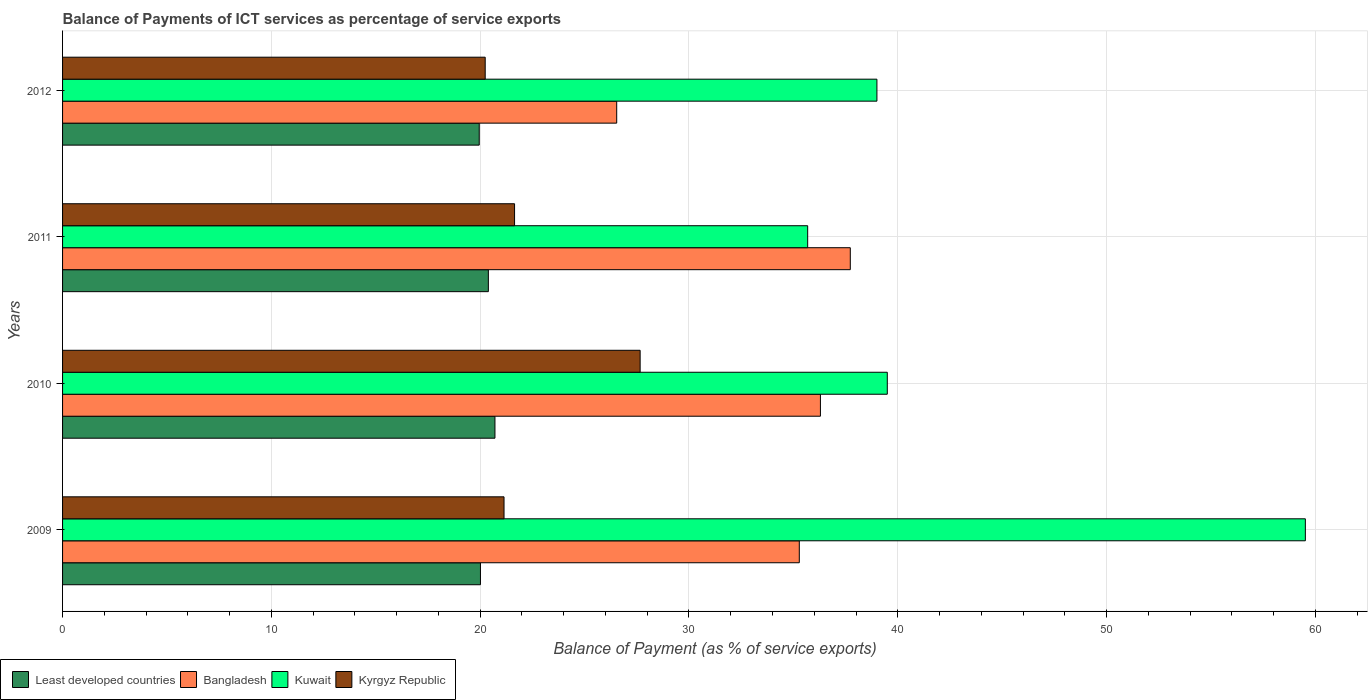How many groups of bars are there?
Provide a short and direct response. 4. Are the number of bars on each tick of the Y-axis equal?
Make the answer very short. Yes. How many bars are there on the 1st tick from the top?
Provide a short and direct response. 4. What is the balance of payments of ICT services in Bangladesh in 2010?
Offer a terse response. 36.29. Across all years, what is the maximum balance of payments of ICT services in Kyrgyz Republic?
Your answer should be compact. 27.66. Across all years, what is the minimum balance of payments of ICT services in Least developed countries?
Keep it short and to the point. 19.95. In which year was the balance of payments of ICT services in Bangladesh maximum?
Your response must be concise. 2011. What is the total balance of payments of ICT services in Kuwait in the graph?
Your answer should be compact. 173.7. What is the difference between the balance of payments of ICT services in Least developed countries in 2011 and that in 2012?
Offer a very short reply. 0.44. What is the difference between the balance of payments of ICT services in Bangladesh in 2010 and the balance of payments of ICT services in Kyrgyz Republic in 2012?
Your answer should be very brief. 16.05. What is the average balance of payments of ICT services in Bangladesh per year?
Provide a short and direct response. 33.96. In the year 2012, what is the difference between the balance of payments of ICT services in Least developed countries and balance of payments of ICT services in Bangladesh?
Offer a very short reply. -6.58. In how many years, is the balance of payments of ICT services in Kuwait greater than 20 %?
Provide a succinct answer. 4. What is the ratio of the balance of payments of ICT services in Kyrgyz Republic in 2011 to that in 2012?
Keep it short and to the point. 1.07. Is the difference between the balance of payments of ICT services in Least developed countries in 2009 and 2011 greater than the difference between the balance of payments of ICT services in Bangladesh in 2009 and 2011?
Offer a terse response. Yes. What is the difference between the highest and the second highest balance of payments of ICT services in Bangladesh?
Offer a terse response. 1.43. What is the difference between the highest and the lowest balance of payments of ICT services in Kyrgyz Republic?
Offer a very short reply. 7.42. Is it the case that in every year, the sum of the balance of payments of ICT services in Bangladesh and balance of payments of ICT services in Kuwait is greater than the sum of balance of payments of ICT services in Least developed countries and balance of payments of ICT services in Kyrgyz Republic?
Your response must be concise. No. What does the 3rd bar from the bottom in 2012 represents?
Provide a short and direct response. Kuwait. Is it the case that in every year, the sum of the balance of payments of ICT services in Bangladesh and balance of payments of ICT services in Kyrgyz Republic is greater than the balance of payments of ICT services in Kuwait?
Your answer should be very brief. No. Are all the bars in the graph horizontal?
Your answer should be compact. Yes. How many years are there in the graph?
Keep it short and to the point. 4. Are the values on the major ticks of X-axis written in scientific E-notation?
Offer a terse response. No. Does the graph contain any zero values?
Your answer should be very brief. No. How many legend labels are there?
Offer a terse response. 4. How are the legend labels stacked?
Offer a terse response. Horizontal. What is the title of the graph?
Provide a succinct answer. Balance of Payments of ICT services as percentage of service exports. Does "Heavily indebted poor countries" appear as one of the legend labels in the graph?
Your answer should be compact. No. What is the label or title of the X-axis?
Keep it short and to the point. Balance of Payment (as % of service exports). What is the Balance of Payment (as % of service exports) in Least developed countries in 2009?
Offer a very short reply. 20.01. What is the Balance of Payment (as % of service exports) in Bangladesh in 2009?
Offer a terse response. 35.28. What is the Balance of Payment (as % of service exports) of Kuwait in 2009?
Give a very brief answer. 59.52. What is the Balance of Payment (as % of service exports) in Kyrgyz Republic in 2009?
Offer a terse response. 21.14. What is the Balance of Payment (as % of service exports) in Least developed countries in 2010?
Provide a short and direct response. 20.71. What is the Balance of Payment (as % of service exports) in Bangladesh in 2010?
Your answer should be compact. 36.29. What is the Balance of Payment (as % of service exports) of Kuwait in 2010?
Keep it short and to the point. 39.5. What is the Balance of Payment (as % of service exports) in Kyrgyz Republic in 2010?
Give a very brief answer. 27.66. What is the Balance of Payment (as % of service exports) in Least developed countries in 2011?
Ensure brevity in your answer.  20.39. What is the Balance of Payment (as % of service exports) in Bangladesh in 2011?
Give a very brief answer. 37.73. What is the Balance of Payment (as % of service exports) of Kuwait in 2011?
Keep it short and to the point. 35.68. What is the Balance of Payment (as % of service exports) in Kyrgyz Republic in 2011?
Your answer should be very brief. 21.65. What is the Balance of Payment (as % of service exports) of Least developed countries in 2012?
Keep it short and to the point. 19.95. What is the Balance of Payment (as % of service exports) of Bangladesh in 2012?
Keep it short and to the point. 26.54. What is the Balance of Payment (as % of service exports) of Kuwait in 2012?
Provide a short and direct response. 39. What is the Balance of Payment (as % of service exports) of Kyrgyz Republic in 2012?
Offer a very short reply. 20.24. Across all years, what is the maximum Balance of Payment (as % of service exports) in Least developed countries?
Make the answer very short. 20.71. Across all years, what is the maximum Balance of Payment (as % of service exports) of Bangladesh?
Your answer should be compact. 37.73. Across all years, what is the maximum Balance of Payment (as % of service exports) in Kuwait?
Provide a succinct answer. 59.52. Across all years, what is the maximum Balance of Payment (as % of service exports) of Kyrgyz Republic?
Keep it short and to the point. 27.66. Across all years, what is the minimum Balance of Payment (as % of service exports) in Least developed countries?
Offer a terse response. 19.95. Across all years, what is the minimum Balance of Payment (as % of service exports) of Bangladesh?
Your answer should be compact. 26.54. Across all years, what is the minimum Balance of Payment (as % of service exports) in Kuwait?
Make the answer very short. 35.68. Across all years, what is the minimum Balance of Payment (as % of service exports) in Kyrgyz Republic?
Your answer should be very brief. 20.24. What is the total Balance of Payment (as % of service exports) of Least developed countries in the graph?
Your answer should be compact. 81.07. What is the total Balance of Payment (as % of service exports) of Bangladesh in the graph?
Give a very brief answer. 135.84. What is the total Balance of Payment (as % of service exports) in Kuwait in the graph?
Ensure brevity in your answer.  173.7. What is the total Balance of Payment (as % of service exports) of Kyrgyz Republic in the graph?
Your response must be concise. 90.69. What is the difference between the Balance of Payment (as % of service exports) in Least developed countries in 2009 and that in 2010?
Your response must be concise. -0.69. What is the difference between the Balance of Payment (as % of service exports) in Bangladesh in 2009 and that in 2010?
Your answer should be compact. -1.01. What is the difference between the Balance of Payment (as % of service exports) in Kuwait in 2009 and that in 2010?
Your answer should be very brief. 20.02. What is the difference between the Balance of Payment (as % of service exports) in Kyrgyz Republic in 2009 and that in 2010?
Provide a succinct answer. -6.52. What is the difference between the Balance of Payment (as % of service exports) in Least developed countries in 2009 and that in 2011?
Your response must be concise. -0.38. What is the difference between the Balance of Payment (as % of service exports) in Bangladesh in 2009 and that in 2011?
Give a very brief answer. -2.44. What is the difference between the Balance of Payment (as % of service exports) of Kuwait in 2009 and that in 2011?
Your answer should be very brief. 23.83. What is the difference between the Balance of Payment (as % of service exports) in Kyrgyz Republic in 2009 and that in 2011?
Ensure brevity in your answer.  -0.5. What is the difference between the Balance of Payment (as % of service exports) of Least developed countries in 2009 and that in 2012?
Offer a terse response. 0.06. What is the difference between the Balance of Payment (as % of service exports) in Bangladesh in 2009 and that in 2012?
Your answer should be very brief. 8.74. What is the difference between the Balance of Payment (as % of service exports) in Kuwait in 2009 and that in 2012?
Offer a very short reply. 20.52. What is the difference between the Balance of Payment (as % of service exports) of Kyrgyz Republic in 2009 and that in 2012?
Provide a succinct answer. 0.9. What is the difference between the Balance of Payment (as % of service exports) in Least developed countries in 2010 and that in 2011?
Keep it short and to the point. 0.32. What is the difference between the Balance of Payment (as % of service exports) of Bangladesh in 2010 and that in 2011?
Provide a succinct answer. -1.43. What is the difference between the Balance of Payment (as % of service exports) in Kuwait in 2010 and that in 2011?
Provide a succinct answer. 3.81. What is the difference between the Balance of Payment (as % of service exports) of Kyrgyz Republic in 2010 and that in 2011?
Make the answer very short. 6.01. What is the difference between the Balance of Payment (as % of service exports) of Least developed countries in 2010 and that in 2012?
Ensure brevity in your answer.  0.75. What is the difference between the Balance of Payment (as % of service exports) of Bangladesh in 2010 and that in 2012?
Provide a short and direct response. 9.76. What is the difference between the Balance of Payment (as % of service exports) in Kuwait in 2010 and that in 2012?
Keep it short and to the point. 0.5. What is the difference between the Balance of Payment (as % of service exports) in Kyrgyz Republic in 2010 and that in 2012?
Provide a succinct answer. 7.42. What is the difference between the Balance of Payment (as % of service exports) in Least developed countries in 2011 and that in 2012?
Your answer should be compact. 0.44. What is the difference between the Balance of Payment (as % of service exports) in Bangladesh in 2011 and that in 2012?
Offer a terse response. 11.19. What is the difference between the Balance of Payment (as % of service exports) of Kuwait in 2011 and that in 2012?
Ensure brevity in your answer.  -3.32. What is the difference between the Balance of Payment (as % of service exports) of Kyrgyz Republic in 2011 and that in 2012?
Your response must be concise. 1.41. What is the difference between the Balance of Payment (as % of service exports) of Least developed countries in 2009 and the Balance of Payment (as % of service exports) of Bangladesh in 2010?
Your answer should be very brief. -16.28. What is the difference between the Balance of Payment (as % of service exports) in Least developed countries in 2009 and the Balance of Payment (as % of service exports) in Kuwait in 2010?
Give a very brief answer. -19.48. What is the difference between the Balance of Payment (as % of service exports) of Least developed countries in 2009 and the Balance of Payment (as % of service exports) of Kyrgyz Republic in 2010?
Make the answer very short. -7.65. What is the difference between the Balance of Payment (as % of service exports) of Bangladesh in 2009 and the Balance of Payment (as % of service exports) of Kuwait in 2010?
Offer a very short reply. -4.21. What is the difference between the Balance of Payment (as % of service exports) of Bangladesh in 2009 and the Balance of Payment (as % of service exports) of Kyrgyz Republic in 2010?
Your response must be concise. 7.62. What is the difference between the Balance of Payment (as % of service exports) in Kuwait in 2009 and the Balance of Payment (as % of service exports) in Kyrgyz Republic in 2010?
Keep it short and to the point. 31.86. What is the difference between the Balance of Payment (as % of service exports) in Least developed countries in 2009 and the Balance of Payment (as % of service exports) in Bangladesh in 2011?
Make the answer very short. -17.71. What is the difference between the Balance of Payment (as % of service exports) in Least developed countries in 2009 and the Balance of Payment (as % of service exports) in Kuwait in 2011?
Your answer should be compact. -15.67. What is the difference between the Balance of Payment (as % of service exports) of Least developed countries in 2009 and the Balance of Payment (as % of service exports) of Kyrgyz Republic in 2011?
Make the answer very short. -1.63. What is the difference between the Balance of Payment (as % of service exports) in Bangladesh in 2009 and the Balance of Payment (as % of service exports) in Kuwait in 2011?
Ensure brevity in your answer.  -0.4. What is the difference between the Balance of Payment (as % of service exports) in Bangladesh in 2009 and the Balance of Payment (as % of service exports) in Kyrgyz Republic in 2011?
Offer a very short reply. 13.64. What is the difference between the Balance of Payment (as % of service exports) in Kuwait in 2009 and the Balance of Payment (as % of service exports) in Kyrgyz Republic in 2011?
Your answer should be compact. 37.87. What is the difference between the Balance of Payment (as % of service exports) in Least developed countries in 2009 and the Balance of Payment (as % of service exports) in Bangladesh in 2012?
Ensure brevity in your answer.  -6.53. What is the difference between the Balance of Payment (as % of service exports) of Least developed countries in 2009 and the Balance of Payment (as % of service exports) of Kuwait in 2012?
Give a very brief answer. -18.99. What is the difference between the Balance of Payment (as % of service exports) in Least developed countries in 2009 and the Balance of Payment (as % of service exports) in Kyrgyz Republic in 2012?
Keep it short and to the point. -0.23. What is the difference between the Balance of Payment (as % of service exports) of Bangladesh in 2009 and the Balance of Payment (as % of service exports) of Kuwait in 2012?
Offer a very short reply. -3.72. What is the difference between the Balance of Payment (as % of service exports) in Bangladesh in 2009 and the Balance of Payment (as % of service exports) in Kyrgyz Republic in 2012?
Your answer should be very brief. 15.04. What is the difference between the Balance of Payment (as % of service exports) in Kuwait in 2009 and the Balance of Payment (as % of service exports) in Kyrgyz Republic in 2012?
Give a very brief answer. 39.28. What is the difference between the Balance of Payment (as % of service exports) in Least developed countries in 2010 and the Balance of Payment (as % of service exports) in Bangladesh in 2011?
Keep it short and to the point. -17.02. What is the difference between the Balance of Payment (as % of service exports) of Least developed countries in 2010 and the Balance of Payment (as % of service exports) of Kuwait in 2011?
Provide a succinct answer. -14.98. What is the difference between the Balance of Payment (as % of service exports) in Least developed countries in 2010 and the Balance of Payment (as % of service exports) in Kyrgyz Republic in 2011?
Ensure brevity in your answer.  -0.94. What is the difference between the Balance of Payment (as % of service exports) of Bangladesh in 2010 and the Balance of Payment (as % of service exports) of Kuwait in 2011?
Keep it short and to the point. 0.61. What is the difference between the Balance of Payment (as % of service exports) in Bangladesh in 2010 and the Balance of Payment (as % of service exports) in Kyrgyz Republic in 2011?
Offer a very short reply. 14.65. What is the difference between the Balance of Payment (as % of service exports) of Kuwait in 2010 and the Balance of Payment (as % of service exports) of Kyrgyz Republic in 2011?
Offer a terse response. 17.85. What is the difference between the Balance of Payment (as % of service exports) of Least developed countries in 2010 and the Balance of Payment (as % of service exports) of Bangladesh in 2012?
Offer a very short reply. -5.83. What is the difference between the Balance of Payment (as % of service exports) in Least developed countries in 2010 and the Balance of Payment (as % of service exports) in Kuwait in 2012?
Keep it short and to the point. -18.29. What is the difference between the Balance of Payment (as % of service exports) of Least developed countries in 2010 and the Balance of Payment (as % of service exports) of Kyrgyz Republic in 2012?
Your answer should be compact. 0.47. What is the difference between the Balance of Payment (as % of service exports) of Bangladesh in 2010 and the Balance of Payment (as % of service exports) of Kuwait in 2012?
Your answer should be very brief. -2.71. What is the difference between the Balance of Payment (as % of service exports) of Bangladesh in 2010 and the Balance of Payment (as % of service exports) of Kyrgyz Republic in 2012?
Provide a succinct answer. 16.05. What is the difference between the Balance of Payment (as % of service exports) of Kuwait in 2010 and the Balance of Payment (as % of service exports) of Kyrgyz Republic in 2012?
Offer a very short reply. 19.26. What is the difference between the Balance of Payment (as % of service exports) of Least developed countries in 2011 and the Balance of Payment (as % of service exports) of Bangladesh in 2012?
Offer a terse response. -6.15. What is the difference between the Balance of Payment (as % of service exports) of Least developed countries in 2011 and the Balance of Payment (as % of service exports) of Kuwait in 2012?
Your answer should be very brief. -18.61. What is the difference between the Balance of Payment (as % of service exports) in Least developed countries in 2011 and the Balance of Payment (as % of service exports) in Kyrgyz Republic in 2012?
Ensure brevity in your answer.  0.15. What is the difference between the Balance of Payment (as % of service exports) of Bangladesh in 2011 and the Balance of Payment (as % of service exports) of Kuwait in 2012?
Provide a short and direct response. -1.27. What is the difference between the Balance of Payment (as % of service exports) of Bangladesh in 2011 and the Balance of Payment (as % of service exports) of Kyrgyz Republic in 2012?
Ensure brevity in your answer.  17.49. What is the difference between the Balance of Payment (as % of service exports) of Kuwait in 2011 and the Balance of Payment (as % of service exports) of Kyrgyz Republic in 2012?
Make the answer very short. 15.44. What is the average Balance of Payment (as % of service exports) in Least developed countries per year?
Offer a terse response. 20.27. What is the average Balance of Payment (as % of service exports) of Bangladesh per year?
Ensure brevity in your answer.  33.96. What is the average Balance of Payment (as % of service exports) in Kuwait per year?
Keep it short and to the point. 43.42. What is the average Balance of Payment (as % of service exports) in Kyrgyz Republic per year?
Make the answer very short. 22.67. In the year 2009, what is the difference between the Balance of Payment (as % of service exports) in Least developed countries and Balance of Payment (as % of service exports) in Bangladesh?
Keep it short and to the point. -15.27. In the year 2009, what is the difference between the Balance of Payment (as % of service exports) in Least developed countries and Balance of Payment (as % of service exports) in Kuwait?
Make the answer very short. -39.51. In the year 2009, what is the difference between the Balance of Payment (as % of service exports) of Least developed countries and Balance of Payment (as % of service exports) of Kyrgyz Republic?
Offer a terse response. -1.13. In the year 2009, what is the difference between the Balance of Payment (as % of service exports) in Bangladesh and Balance of Payment (as % of service exports) in Kuwait?
Make the answer very short. -24.24. In the year 2009, what is the difference between the Balance of Payment (as % of service exports) of Bangladesh and Balance of Payment (as % of service exports) of Kyrgyz Republic?
Give a very brief answer. 14.14. In the year 2009, what is the difference between the Balance of Payment (as % of service exports) in Kuwait and Balance of Payment (as % of service exports) in Kyrgyz Republic?
Your response must be concise. 38.38. In the year 2010, what is the difference between the Balance of Payment (as % of service exports) in Least developed countries and Balance of Payment (as % of service exports) in Bangladesh?
Give a very brief answer. -15.59. In the year 2010, what is the difference between the Balance of Payment (as % of service exports) in Least developed countries and Balance of Payment (as % of service exports) in Kuwait?
Provide a succinct answer. -18.79. In the year 2010, what is the difference between the Balance of Payment (as % of service exports) in Least developed countries and Balance of Payment (as % of service exports) in Kyrgyz Republic?
Give a very brief answer. -6.95. In the year 2010, what is the difference between the Balance of Payment (as % of service exports) in Bangladesh and Balance of Payment (as % of service exports) in Kuwait?
Offer a terse response. -3.2. In the year 2010, what is the difference between the Balance of Payment (as % of service exports) of Bangladesh and Balance of Payment (as % of service exports) of Kyrgyz Republic?
Your answer should be compact. 8.63. In the year 2010, what is the difference between the Balance of Payment (as % of service exports) of Kuwait and Balance of Payment (as % of service exports) of Kyrgyz Republic?
Your answer should be very brief. 11.84. In the year 2011, what is the difference between the Balance of Payment (as % of service exports) in Least developed countries and Balance of Payment (as % of service exports) in Bangladesh?
Provide a short and direct response. -17.33. In the year 2011, what is the difference between the Balance of Payment (as % of service exports) of Least developed countries and Balance of Payment (as % of service exports) of Kuwait?
Your response must be concise. -15.29. In the year 2011, what is the difference between the Balance of Payment (as % of service exports) in Least developed countries and Balance of Payment (as % of service exports) in Kyrgyz Republic?
Offer a very short reply. -1.26. In the year 2011, what is the difference between the Balance of Payment (as % of service exports) of Bangladesh and Balance of Payment (as % of service exports) of Kuwait?
Keep it short and to the point. 2.04. In the year 2011, what is the difference between the Balance of Payment (as % of service exports) in Bangladesh and Balance of Payment (as % of service exports) in Kyrgyz Republic?
Offer a terse response. 16.08. In the year 2011, what is the difference between the Balance of Payment (as % of service exports) of Kuwait and Balance of Payment (as % of service exports) of Kyrgyz Republic?
Make the answer very short. 14.04. In the year 2012, what is the difference between the Balance of Payment (as % of service exports) of Least developed countries and Balance of Payment (as % of service exports) of Bangladesh?
Offer a terse response. -6.58. In the year 2012, what is the difference between the Balance of Payment (as % of service exports) of Least developed countries and Balance of Payment (as % of service exports) of Kuwait?
Make the answer very short. -19.05. In the year 2012, what is the difference between the Balance of Payment (as % of service exports) in Least developed countries and Balance of Payment (as % of service exports) in Kyrgyz Republic?
Your response must be concise. -0.29. In the year 2012, what is the difference between the Balance of Payment (as % of service exports) of Bangladesh and Balance of Payment (as % of service exports) of Kuwait?
Make the answer very short. -12.46. In the year 2012, what is the difference between the Balance of Payment (as % of service exports) of Bangladesh and Balance of Payment (as % of service exports) of Kyrgyz Republic?
Your response must be concise. 6.3. In the year 2012, what is the difference between the Balance of Payment (as % of service exports) of Kuwait and Balance of Payment (as % of service exports) of Kyrgyz Republic?
Provide a succinct answer. 18.76. What is the ratio of the Balance of Payment (as % of service exports) of Least developed countries in 2009 to that in 2010?
Give a very brief answer. 0.97. What is the ratio of the Balance of Payment (as % of service exports) in Bangladesh in 2009 to that in 2010?
Offer a very short reply. 0.97. What is the ratio of the Balance of Payment (as % of service exports) in Kuwait in 2009 to that in 2010?
Ensure brevity in your answer.  1.51. What is the ratio of the Balance of Payment (as % of service exports) of Kyrgyz Republic in 2009 to that in 2010?
Give a very brief answer. 0.76. What is the ratio of the Balance of Payment (as % of service exports) of Least developed countries in 2009 to that in 2011?
Provide a short and direct response. 0.98. What is the ratio of the Balance of Payment (as % of service exports) of Bangladesh in 2009 to that in 2011?
Your answer should be compact. 0.94. What is the ratio of the Balance of Payment (as % of service exports) in Kuwait in 2009 to that in 2011?
Give a very brief answer. 1.67. What is the ratio of the Balance of Payment (as % of service exports) of Kyrgyz Republic in 2009 to that in 2011?
Your answer should be very brief. 0.98. What is the ratio of the Balance of Payment (as % of service exports) of Bangladesh in 2009 to that in 2012?
Give a very brief answer. 1.33. What is the ratio of the Balance of Payment (as % of service exports) of Kuwait in 2009 to that in 2012?
Your answer should be very brief. 1.53. What is the ratio of the Balance of Payment (as % of service exports) in Kyrgyz Republic in 2009 to that in 2012?
Provide a short and direct response. 1.04. What is the ratio of the Balance of Payment (as % of service exports) of Least developed countries in 2010 to that in 2011?
Your response must be concise. 1.02. What is the ratio of the Balance of Payment (as % of service exports) of Bangladesh in 2010 to that in 2011?
Provide a succinct answer. 0.96. What is the ratio of the Balance of Payment (as % of service exports) in Kuwait in 2010 to that in 2011?
Provide a short and direct response. 1.11. What is the ratio of the Balance of Payment (as % of service exports) in Kyrgyz Republic in 2010 to that in 2011?
Your answer should be very brief. 1.28. What is the ratio of the Balance of Payment (as % of service exports) in Least developed countries in 2010 to that in 2012?
Provide a short and direct response. 1.04. What is the ratio of the Balance of Payment (as % of service exports) in Bangladesh in 2010 to that in 2012?
Give a very brief answer. 1.37. What is the ratio of the Balance of Payment (as % of service exports) of Kuwait in 2010 to that in 2012?
Keep it short and to the point. 1.01. What is the ratio of the Balance of Payment (as % of service exports) of Kyrgyz Republic in 2010 to that in 2012?
Your answer should be very brief. 1.37. What is the ratio of the Balance of Payment (as % of service exports) of Least developed countries in 2011 to that in 2012?
Offer a terse response. 1.02. What is the ratio of the Balance of Payment (as % of service exports) of Bangladesh in 2011 to that in 2012?
Provide a short and direct response. 1.42. What is the ratio of the Balance of Payment (as % of service exports) in Kuwait in 2011 to that in 2012?
Offer a very short reply. 0.92. What is the ratio of the Balance of Payment (as % of service exports) in Kyrgyz Republic in 2011 to that in 2012?
Your answer should be compact. 1.07. What is the difference between the highest and the second highest Balance of Payment (as % of service exports) in Least developed countries?
Make the answer very short. 0.32. What is the difference between the highest and the second highest Balance of Payment (as % of service exports) of Bangladesh?
Make the answer very short. 1.43. What is the difference between the highest and the second highest Balance of Payment (as % of service exports) in Kuwait?
Keep it short and to the point. 20.02. What is the difference between the highest and the second highest Balance of Payment (as % of service exports) of Kyrgyz Republic?
Offer a terse response. 6.01. What is the difference between the highest and the lowest Balance of Payment (as % of service exports) of Least developed countries?
Your answer should be compact. 0.75. What is the difference between the highest and the lowest Balance of Payment (as % of service exports) of Bangladesh?
Offer a terse response. 11.19. What is the difference between the highest and the lowest Balance of Payment (as % of service exports) of Kuwait?
Provide a short and direct response. 23.83. What is the difference between the highest and the lowest Balance of Payment (as % of service exports) in Kyrgyz Republic?
Offer a terse response. 7.42. 